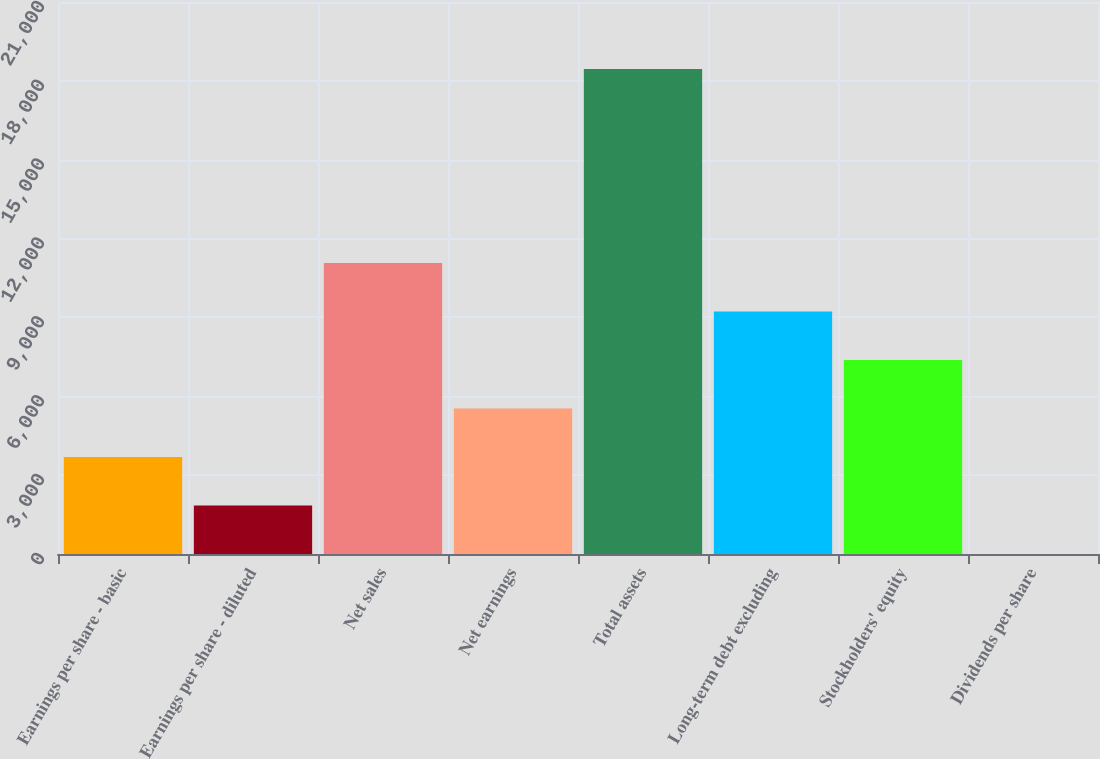Convert chart to OTSL. <chart><loc_0><loc_0><loc_500><loc_500><bar_chart><fcel>Earnings per share - basic<fcel>Earnings per share - diluted<fcel>Net sales<fcel>Net earnings<fcel>Total assets<fcel>Long-term debt excluding<fcel>Stockholders' equity<fcel>Dividends per share<nl><fcel>3690.48<fcel>1845.79<fcel>11070<fcel>5535.17<fcel>18448<fcel>9224.55<fcel>7379.86<fcel>1.1<nl></chart> 